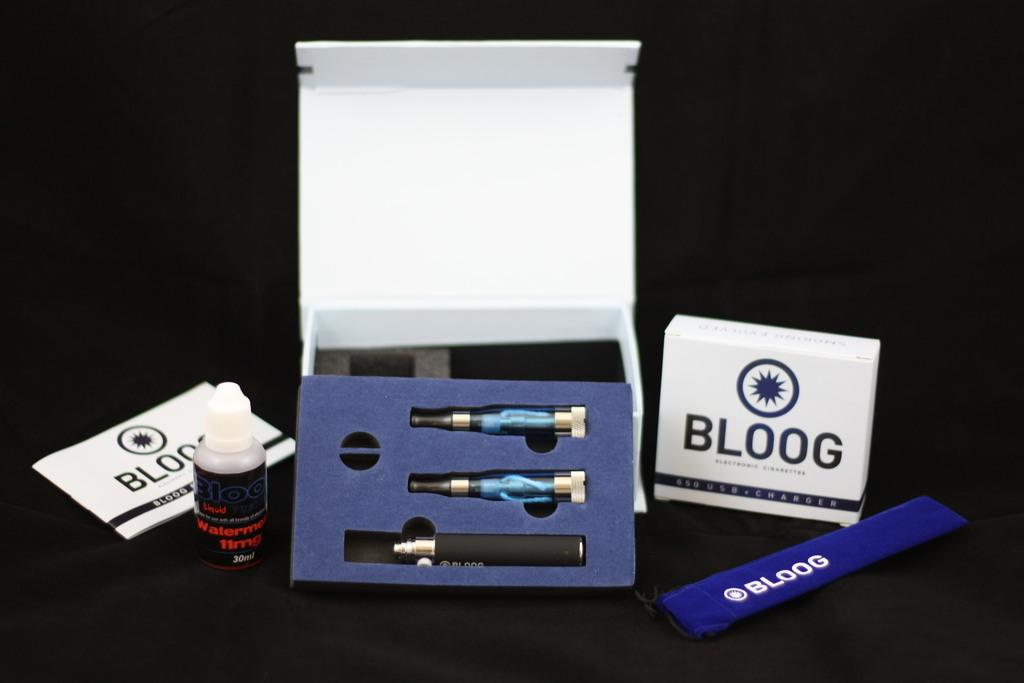What is one of the objects in the image? There is a book in the image. What else can be seen in the image besides the book? There is a tube and boxes in the image. Are there any other objects in the image that are not specified? Yes, there are some unspecified objects in the image. What is the color of the background in the image? The background of the image is dark. Can you tell me what type of hat the goat is wearing in the image? There is no goat or hat present in the image. What color is the apple in the image? There is no apple present in the image. 